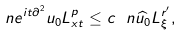<formula> <loc_0><loc_0><loc_500><loc_500>\ n { e ^ { i t \partial ^ { 2 } } u _ { 0 } } { L ^ { p } _ { x t } } \leq c \ n { \widehat { u _ { 0 } } } { L ^ { r ^ { \prime } } _ { \xi } } ,</formula> 